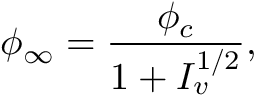<formula> <loc_0><loc_0><loc_500><loc_500>\phi _ { \infty } = \frac { \phi _ { c } } { 1 + I _ { v } ^ { 1 / 2 } } ,</formula> 